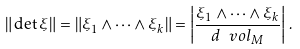Convert formula to latex. <formula><loc_0><loc_0><loc_500><loc_500>\| \det \xi \| = \| \xi _ { 1 } \wedge \cdots \wedge \xi _ { k } \| = \left | \frac { \xi _ { 1 } \wedge \cdots \wedge \xi _ { k } } { d \ v o l _ { M } } \right | \, .</formula> 